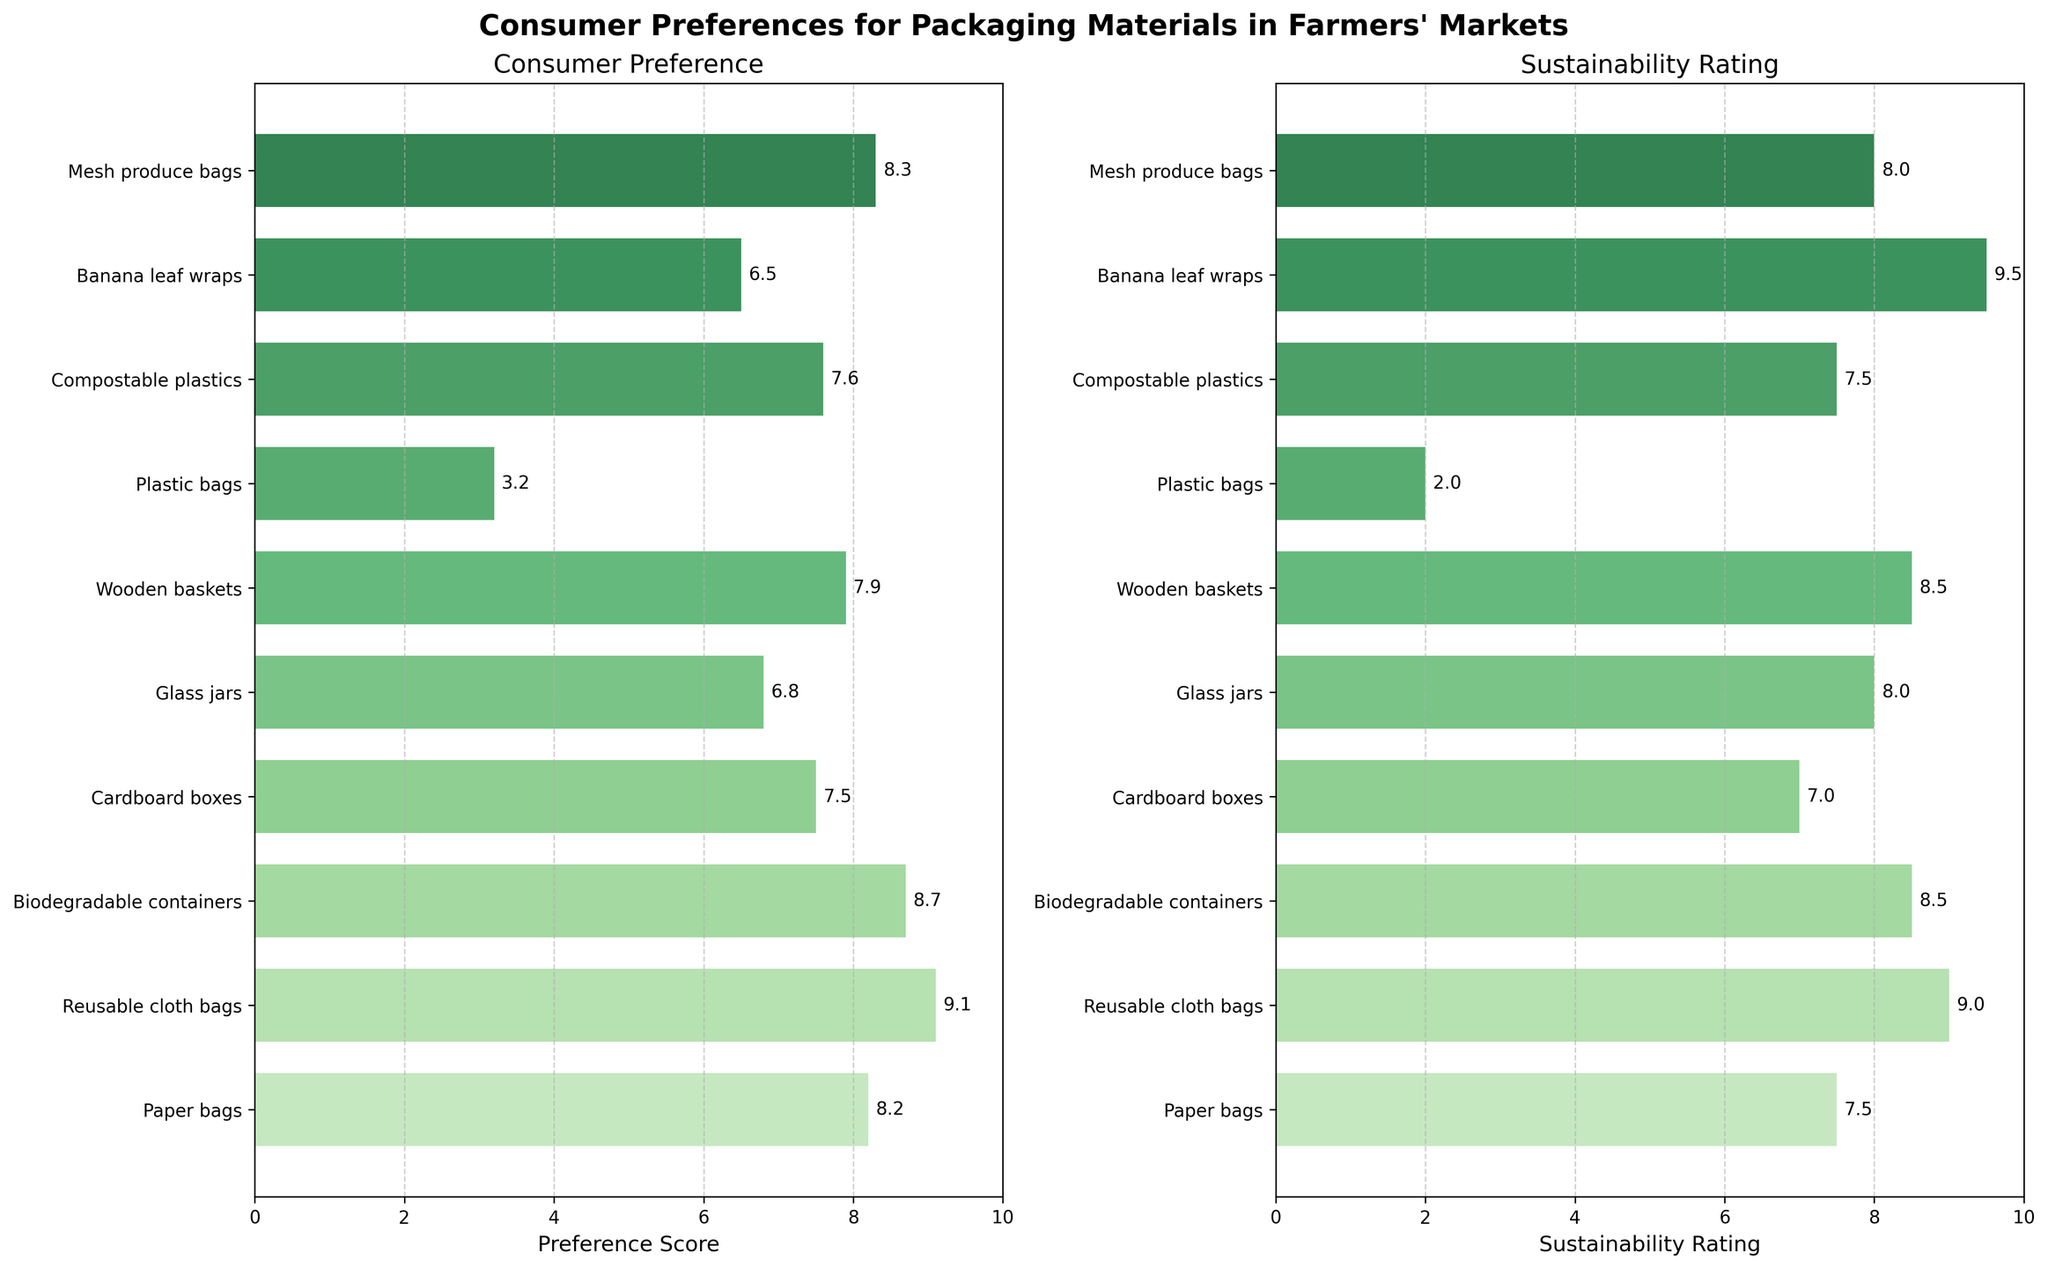Which packaging material has the highest preference score? By looking at the Consumer Preference subplot on the left, the bar with the highest preference score is identified.
Answer: Reusable cloth bags Which material has a lower sustainability rating than its preference score? Compare each material's preference score and sustainability rating from the left and right subplots.
Answer: Paper bags What's the average sustainability rating of all the materials shown? Sum all the sustainability ratings and divide by the number of materials: (7.5 + 9.0 + 8.5 + 7.0 + 8.0 + 8.5 + 2.0 + 7.5 + 9.5 + 8.0) / 10. The total is 75.5, and dividing by 10 gives 7.55.
Answer: 7.55 Which two materials have equal sustainability ratings? Look for bars that reach the same point on the sustainability axis: Paper bags and Compostable plastics both have a sustainability rating of 7.5.
Answer: Paper bags and Compostable plastics Between biodegradable containers and mesh produce bags, which is preferred by consumers? Compare the bar lengths for biodegradable containers and mesh produce bags on the Consumer Preference subplot.
Answer: Mesh produce bags Which material has the lowest preference score? Identify the shortest bar in the Consumer Preference subplot.
Answer: Plastic bags What's the average preference score for biodegradable containers, compostable plastics, and mesh produce bags? Sum their preference scores and divide by 3: (8.7 + 7.6 + 8.3) / 3. The total is 24.6, and dividing by 3 gives 8.2.
Answer: 8.2 What's the mean of the sustainability rating for the top three preferred materials? Determine the sustainability ratings of the top three materials based on preference scores and calculate their mean: Reusable cloth bags (9.0), Biodegradable containers (8.5), Mesh produce bags (8.0). Their sum is 25.5, and dividing by 3 gives 8.5.
Answer: 8.5 